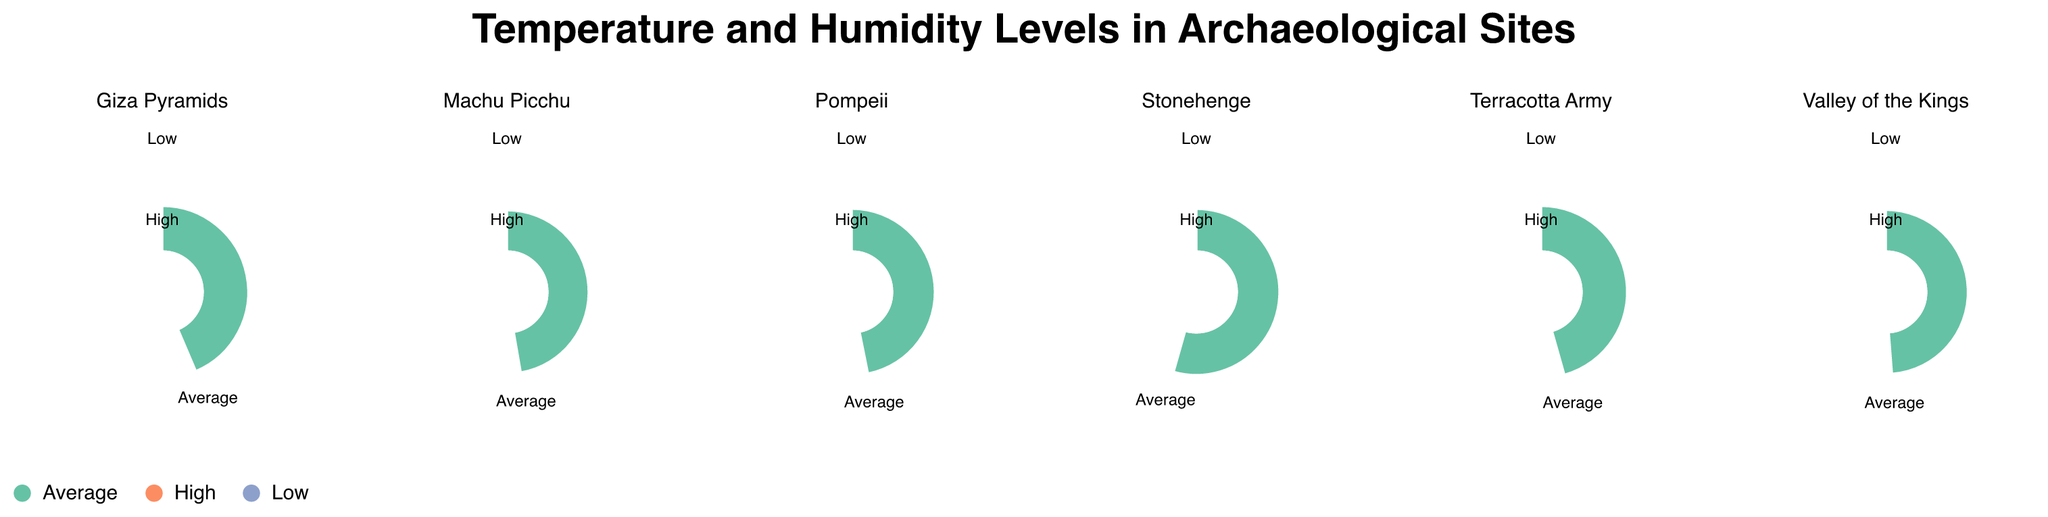How many archaeological sites are displayed in the figure? The figure consists of multiple subplots, each representing a different archaeological site. By counting the unique subplots, we can determine there are six sites in total: Giza Pyramids, Pompeii, Machu Picchu, Terracotta Army, Stonehenge, and Valley of the Kings.
Answer: Six Which site has the highest average temperature? Referring to the average temperature (marked as "Average" in the condition label) for each site, Valley of the Kings has an average temperature of 41.0°C, which is the highest among all sites.
Answer: Valley of the Kings What is the range of humidity levels for Stonehenge? The humidity levels for Stonehenge are given for different conditions: 78.1% (Average), 73.0% (High), and 82.9% (Low). To find the range, we subtract the lowest humidity from the highest humidity: 82.9% - 73.0% = 9.9%.
Answer: 9.9% How does the humidity level at Machu Picchu during low conditions compare to high conditions? For Machu Picchu, the humidity level during low conditions is 87.8%, and during high conditions, it is 79.2%. Comparing these, the humidity level during low conditions is higher than during high conditions.
Answer: Higher In which site is the difference between high and low temperatures the greatest? To find the site with the greatest temperature difference between high and low conditions, we calculate for each site: 
- Giza Pyramids: 38.6°C - 30.8°C = 7.8°C
- Pompeii: 29.3°C - 21.4°C = 7.9°C
- Machu Picchu: 21.6°C - 16.1°C = 5.5°C
- Terracotta Army: 15.4°C - 9.7°C = 5.7°C
- Stonehenge: 13.0°C - 7.3°C = 5.7°C
- Valley of the Kings: 45.2°C - 37.0°C = 8.2°C
Valley of the Kings has the greatest difference at 8.2°C.
Answer: Valley of the Kings Which condition appears to have the most notable impact on both temperature and humidity levels across all sites? Examining the condition labels and their respective temperature and humidity values across all sites, "High" conditions generally show the most significant variations in temperature and decrease in humidity levels when compared to "Low" and "Average" conditions. This difference is particularly noticeable in sites like Giza Pyramids and Valley of the Kings.
Answer: High Is there a site where the average humidity is below 20%? Reviewing the average humidity values for each site, only Valley of the Kings has an average humidity level below 20%, specifically at 12.5%.
Answer: Yes, Valley of the Kings 